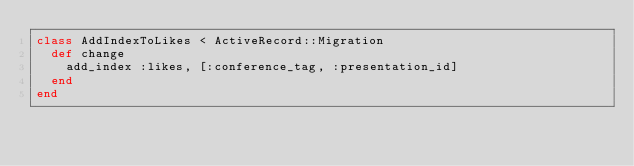<code> <loc_0><loc_0><loc_500><loc_500><_Ruby_>class AddIndexToLikes < ActiveRecord::Migration
  def change
    add_index :likes, [:conference_tag, :presentation_id]
  end
end
</code> 